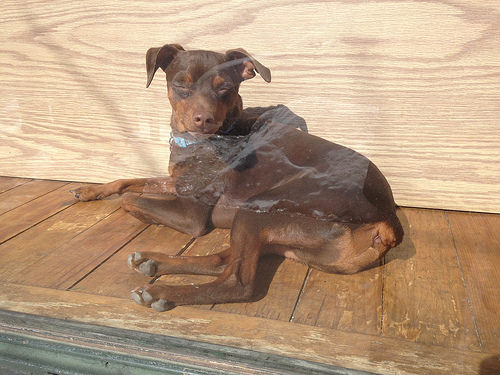<image>
Is there a dog in front of the wall? Yes. The dog is positioned in front of the wall, appearing closer to the camera viewpoint. 